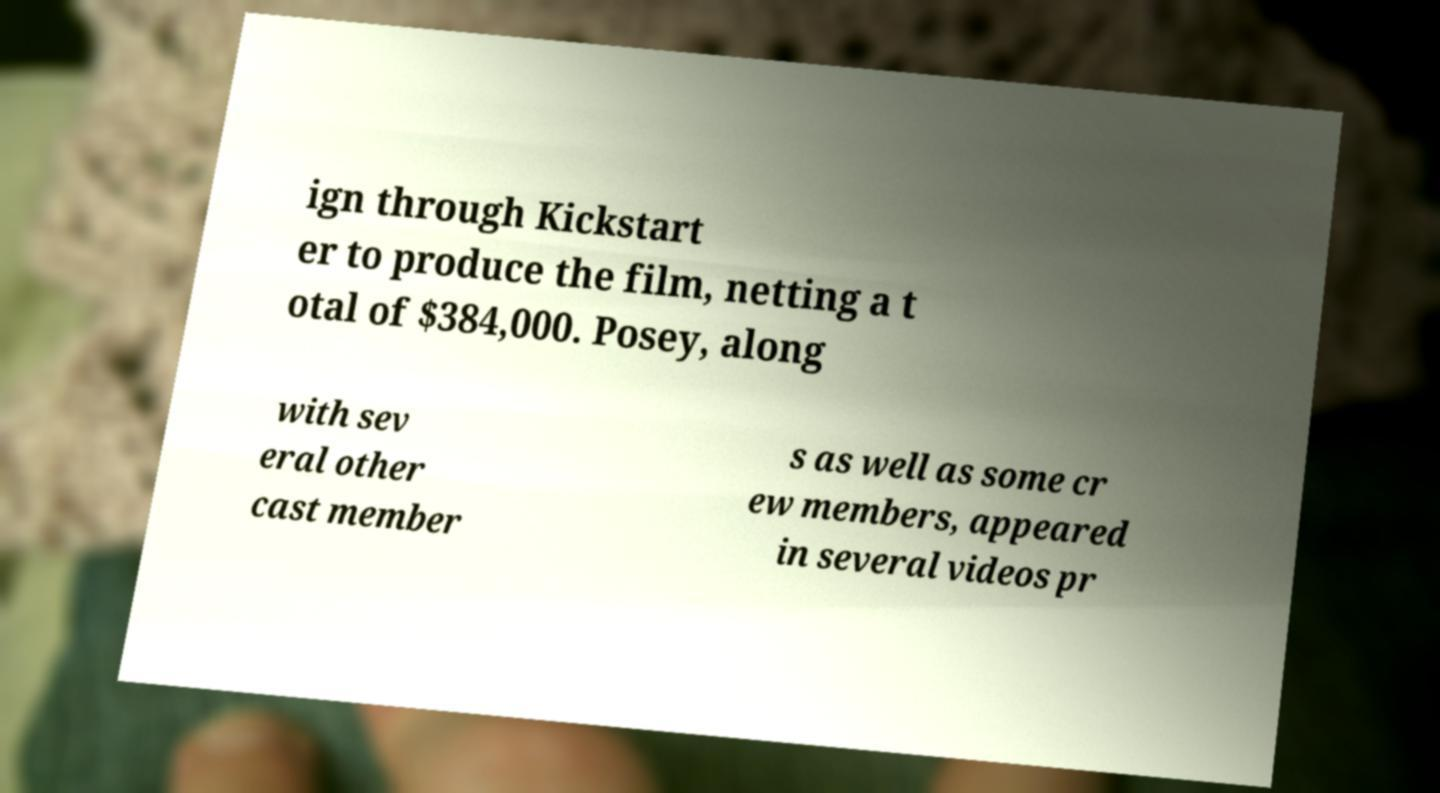Can you read and provide the text displayed in the image?This photo seems to have some interesting text. Can you extract and type it out for me? ign through Kickstart er to produce the film, netting a t otal of $384,000. Posey, along with sev eral other cast member s as well as some cr ew members, appeared in several videos pr 